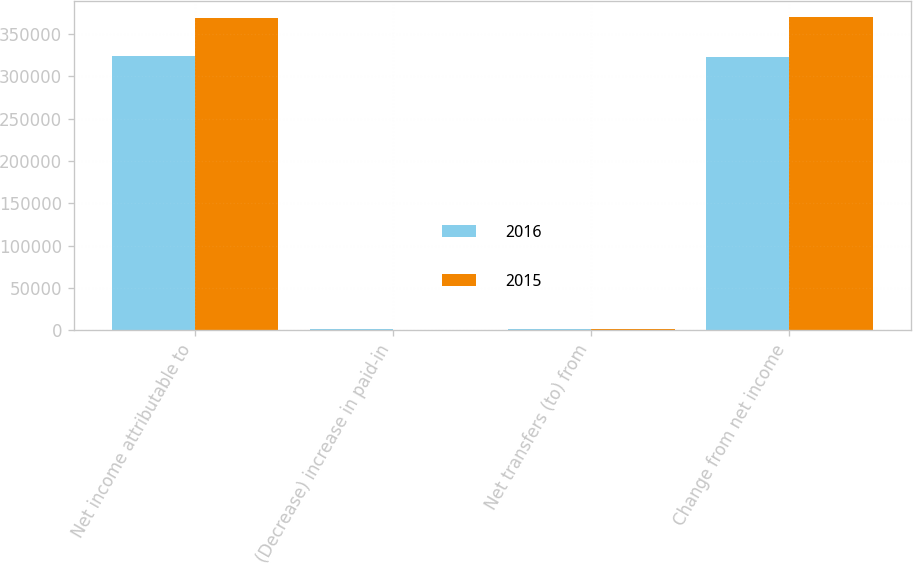Convert chart to OTSL. <chart><loc_0><loc_0><loc_500><loc_500><stacked_bar_chart><ecel><fcel>Net income attributable to<fcel>(Decrease) increase in paid-in<fcel>Net transfers (to) from<fcel>Change from net income<nl><fcel>2016<fcel>324132<fcel>1611<fcel>1611<fcel>322521<nl><fcel>2015<fcel>369009<fcel>345<fcel>1439<fcel>370448<nl></chart> 